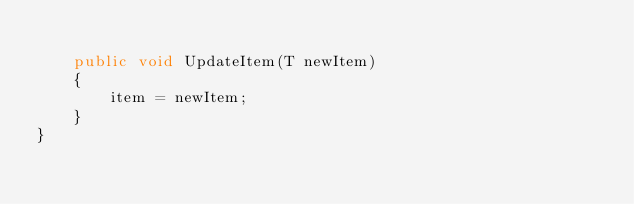<code> <loc_0><loc_0><loc_500><loc_500><_C#_>
    public void UpdateItem(T newItem)
    {
        item = newItem;
    }
}</code> 